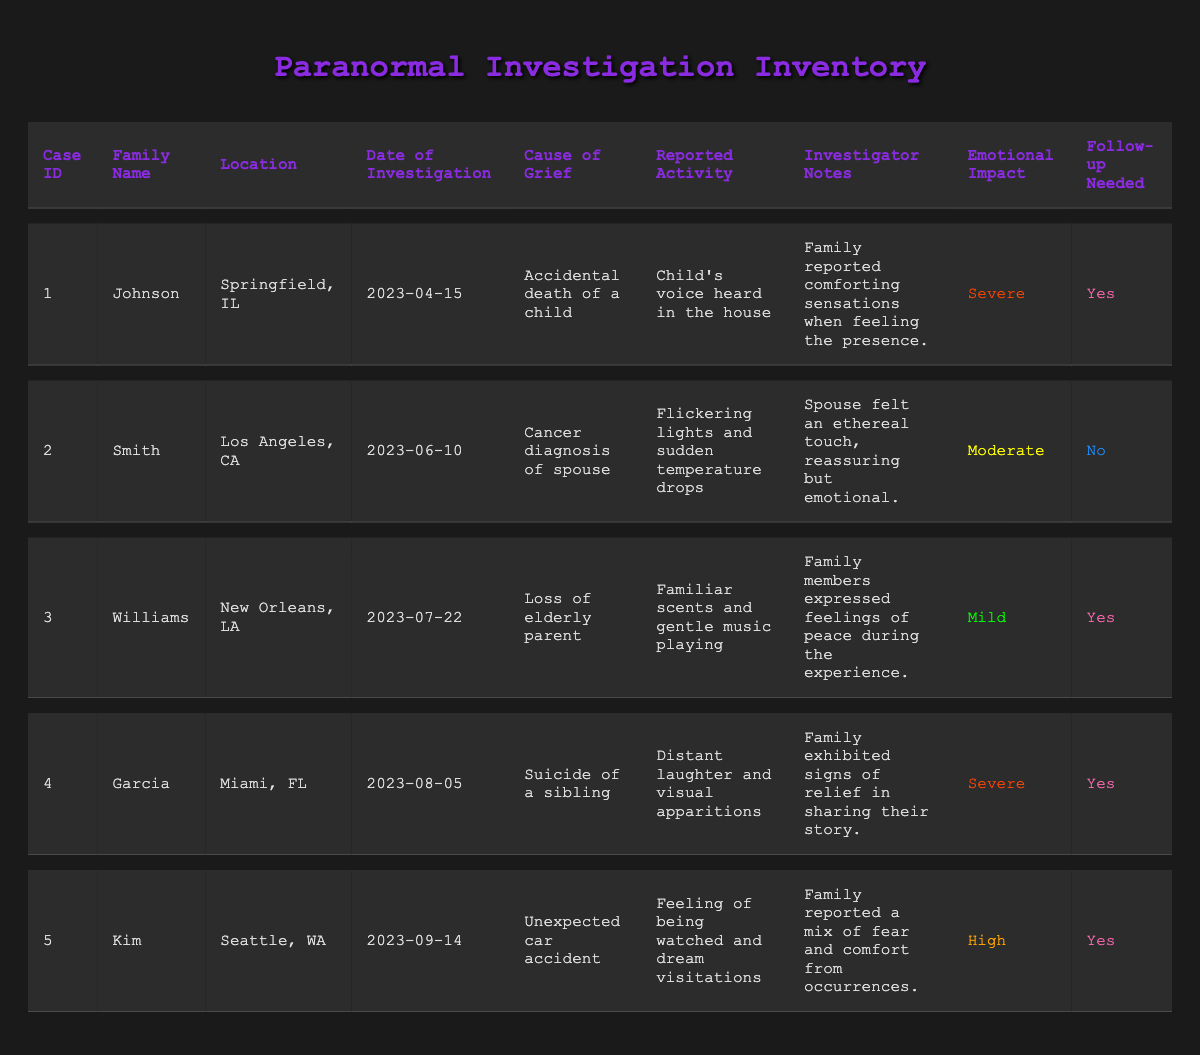What is the location of the Johnson case? The Johnson case is listed in the table under the "Location" column for case ID 1, and it is Springfield, IL.
Answer: Springfield, IL Which family experienced emotional trauma due to the suicide of a sibling? By referring to the "Cause of Grief" column, the Garcia family experienced emotional trauma due to the "Suicide of a sibling," which is found in case ID 4.
Answer: Garcia How many investigations require follow-ups? To determine this, I check the "Follow-up Needed" column. Five cases are listed, and rows 1, 3, 4, and 5 indicate that follow-ups are needed. Counting these gives a total of four investigations needing follow-ups.
Answer: 4 What emotional impact did the Kim family report? The emotional impact for the Kim family is found under the "Emotional Impact" column. Looking at case ID 5 reveals it is categorized as "High."
Answer: High Did any family report comfort from paranormal activity? I check the "Investigator Notes" for each case. The Johnson, Williams, Garcia, and Kim families all expressed feelings of comfort, indicating that yes, multiple families reported comfort from paranormal activity.
Answer: Yes How many families reported a severe emotional impact? I examine the "Emotional Impact" column and count the rows marked as "Severe," specifically for the Johnson and Garcia cases, making a total of two families with severe emotional impact.
Answer: 2 Which reported activity was associated with the loss of an elderly parent? I locate the "Reported Activity" corresponding to the "Cause of Grief" listed as "Loss of elderly parent" in case ID 3, which shows the reported activity is "Familiar scents and gentle music playing."
Answer: Familiar scents and gentle music playing What is the average emotional impact rating for all investigated families? I assign numerical values to the emotional impact: Severe (3), High (2), Moderate (1), Mild (0). The cases have emotional impacts of Severe (1), Moderate (2), Mild (3), Severe (4), and High (5). Adding these values (3 + 2 + 0 + 3 + 1) gives 9 for 5 cases, leading to an average of 9/5 = 1.8. Consequently, translating back to the qualitative rating points gives an average impact of Moderate.
Answer: Moderate Did the Smith family require a follow-up? Look at the "Follow-up Needed" column for the Smith case, which shows "No" under case ID 2, indicating they did not require a follow-up.
Answer: No 